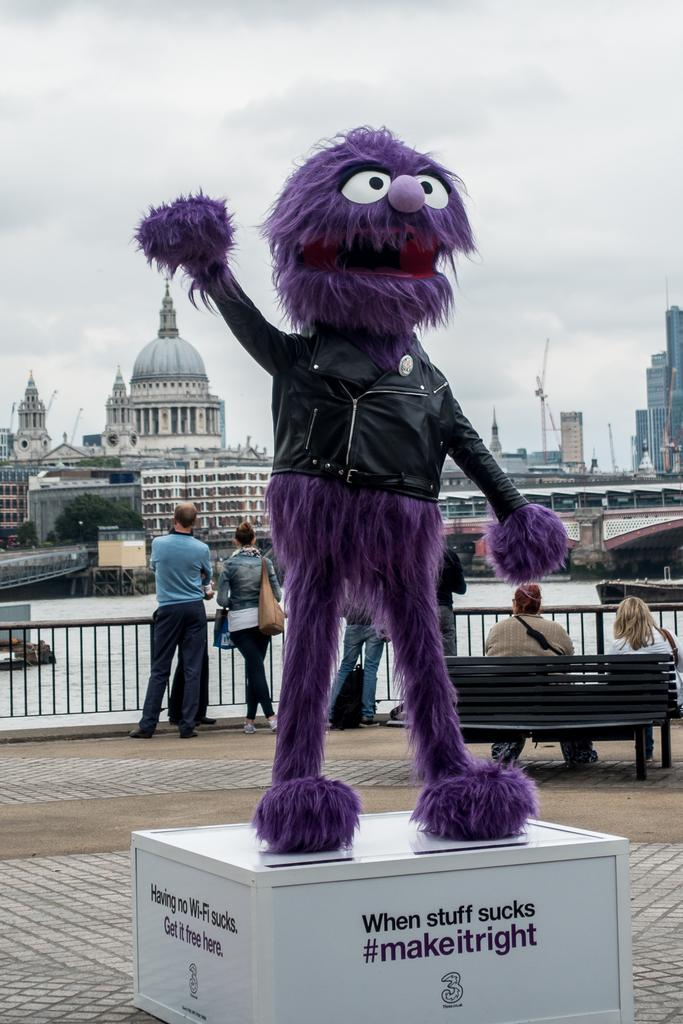What is placed on the box in the image? There is a doll placed on a box in the image. Who or what else can be seen in the image? There are people and benches in the image. What is the purpose of the fence in the image? The purpose of the fence in the image is not specified, but it could be for enclosing an area or providing a boundary. What is the boat's position in relation to the water in the image? There is a boat above the water in the image. What can be seen in the background of the image? In the background of the image, there are trees, buildings, and the sky. How many chickens are flying in space in the image? There are no chickens or any indication of space in the image. 